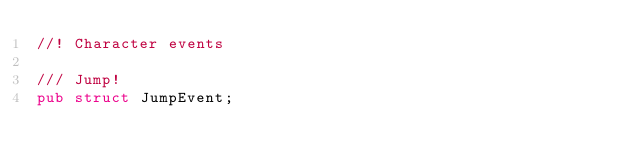<code> <loc_0><loc_0><loc_500><loc_500><_Rust_>//! Character events

/// Jump!
pub struct JumpEvent;
</code> 